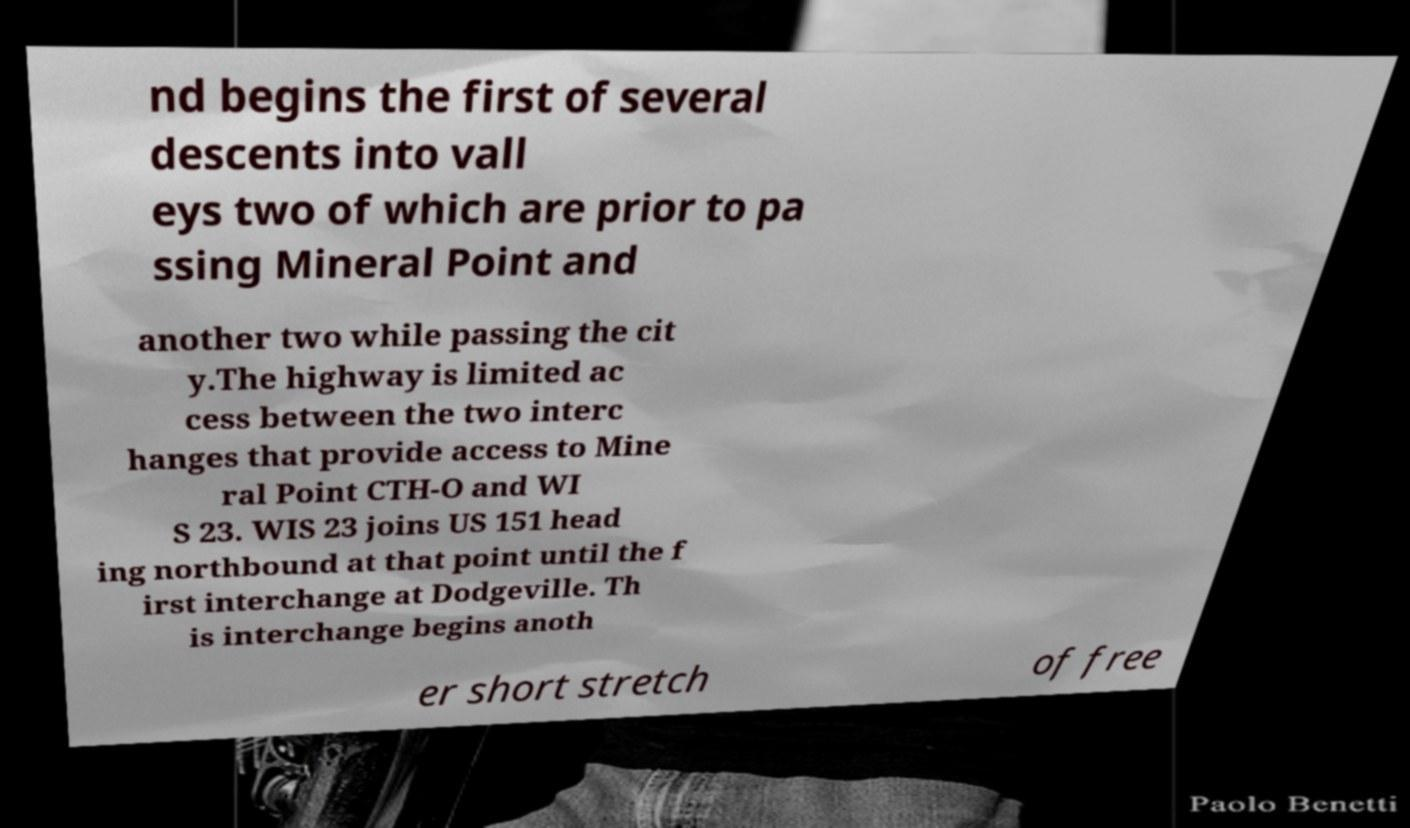What messages or text are displayed in this image? I need them in a readable, typed format. nd begins the first of several descents into vall eys two of which are prior to pa ssing Mineral Point and another two while passing the cit y.The highway is limited ac cess between the two interc hanges that provide access to Mine ral Point CTH-O and WI S 23. WIS 23 joins US 151 head ing northbound at that point until the f irst interchange at Dodgeville. Th is interchange begins anoth er short stretch of free 